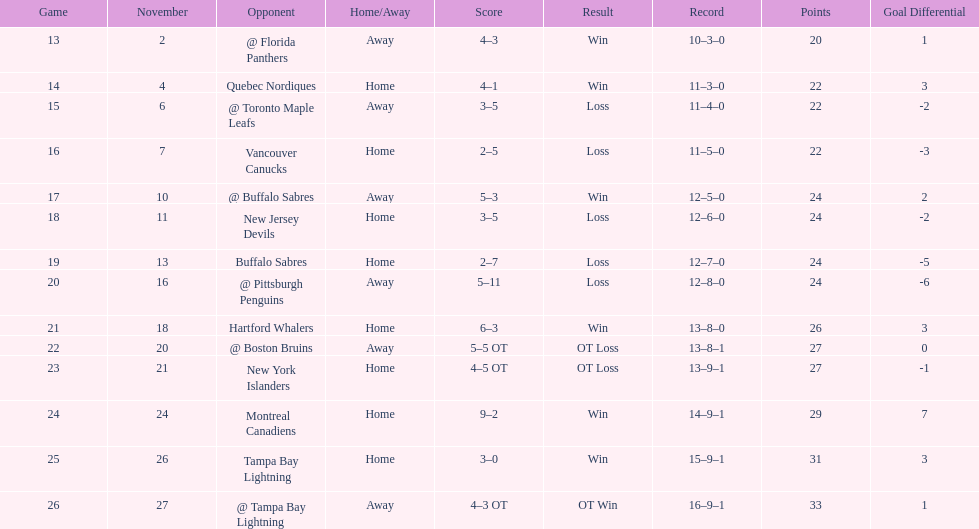What are the teams in the atlantic division? Quebec Nordiques, Vancouver Canucks, New Jersey Devils, Buffalo Sabres, Hartford Whalers, New York Islanders, Montreal Canadiens, Tampa Bay Lightning. Which of those scored fewer points than the philadelphia flyers? Tampa Bay Lightning. 